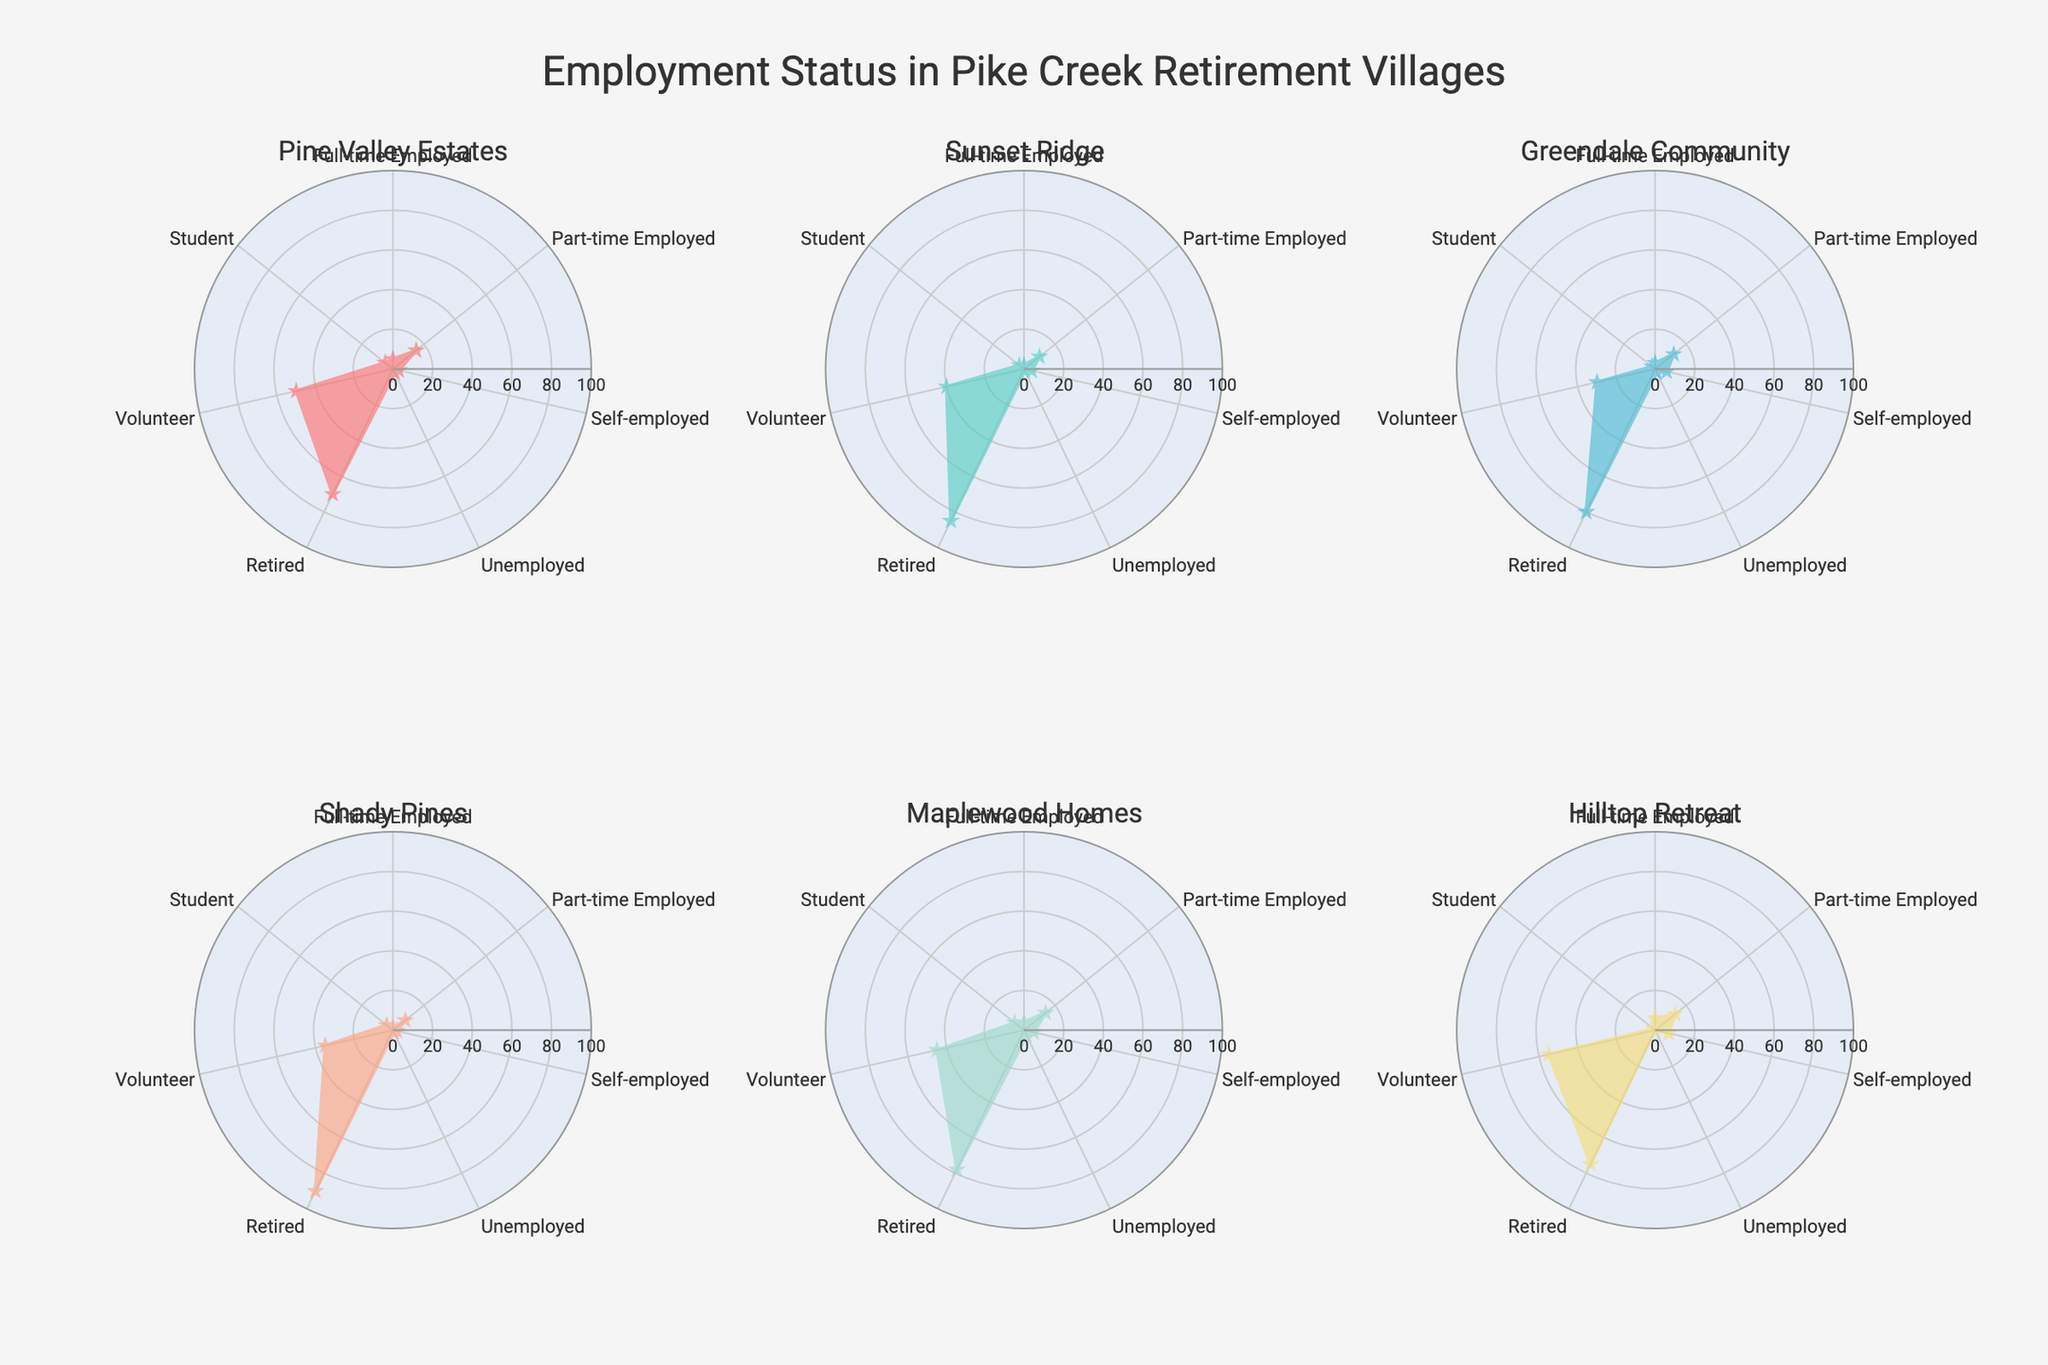Which village has the highest number of retirees? By looking at each subplot, the highest point along the 'Retired' axis is at Shady Pines with 90 retirees.
Answer: Shady Pines Which village has the least number of full-time employed residents? We need to find the lowest value along the 'Full-time Employed' axis across all subplots. Shady Pines has the lowest value, which is 1.
Answer: Shady Pines What is the total number of volunteers across all villages? Sum the 'Volunteer' values: 50 (Pine Valley Estates) + 40 (Sunset Ridge) + 30 (Greendale Community) + 35 (Shady Pines) + 45 (Maplewood Homes) + 55 (Hilltop Retreat) = 255
Answer: 255 How does the number of unemployed residents in Pine Valley Estates compare to Sunset Ridge? Pine Valley Estates has 2 unemployed residents while Sunset Ridge has 1. Therefore, Pine Valley Estates has 1 more unemployed resident than Sunset Ridge.
Answer: Pine Valley Estates has 1 more Which village has the most balanced distribution of employment statuses? By examining the radar plots, Hilltop Retreat and Maplewood Homes have a more evenly spread pattern among all statuses compared to others, with Hilltop Retreat slightly more balanced.
Answer: Hilltop Retreat Is there any village where the number of students exceeds the number of unemployed residents? By checking the subplots, Maplewood Homes has 6 students and 3 unemployed residents, making it the only village where students exceed unemployed.
Answer: Maplewood Homes Are there any villages with no self-employed residents? Check the 'Self-employed' axis for zeros. All villages show some value, indicating none have zero self-employed residents.
Answer: No Between Pine Valley Estates and Hilltop Retreat, which has a higher number of part-time employed residents? Pine Valley Estates has 15 part-time employed, while Hilltop Retreat has 13. Therefore, Pine Valley Estates has more part-time employed residents.
Answer: Pine Valley Estates What is the average number of retired residents across the six villages? Sum the 'Retired' values: (70 + 85 + 80 + 90 + 78 + 75) = 478, then divide by 6 (number of villages), resulting in 478 / 6 ≈ 79.67.
Answer: 79.67 How many villages have a higher number of self-employed residents than students? Compare values for ‘Self-employed’ and ‘Student’ for each village: Pine Valley Estates (3 vs. 5), Sunset Ridge (4 vs. 3), Greendale Community (6 vs. 2), Shady Pines (2 vs. 4), Maplewood Homes (5 vs. 6), Hilltop Retreat (7 vs. 1). Three villages (Sunset Ridge, Greendale Community, Hilltop Retreat).
Answer: 3 